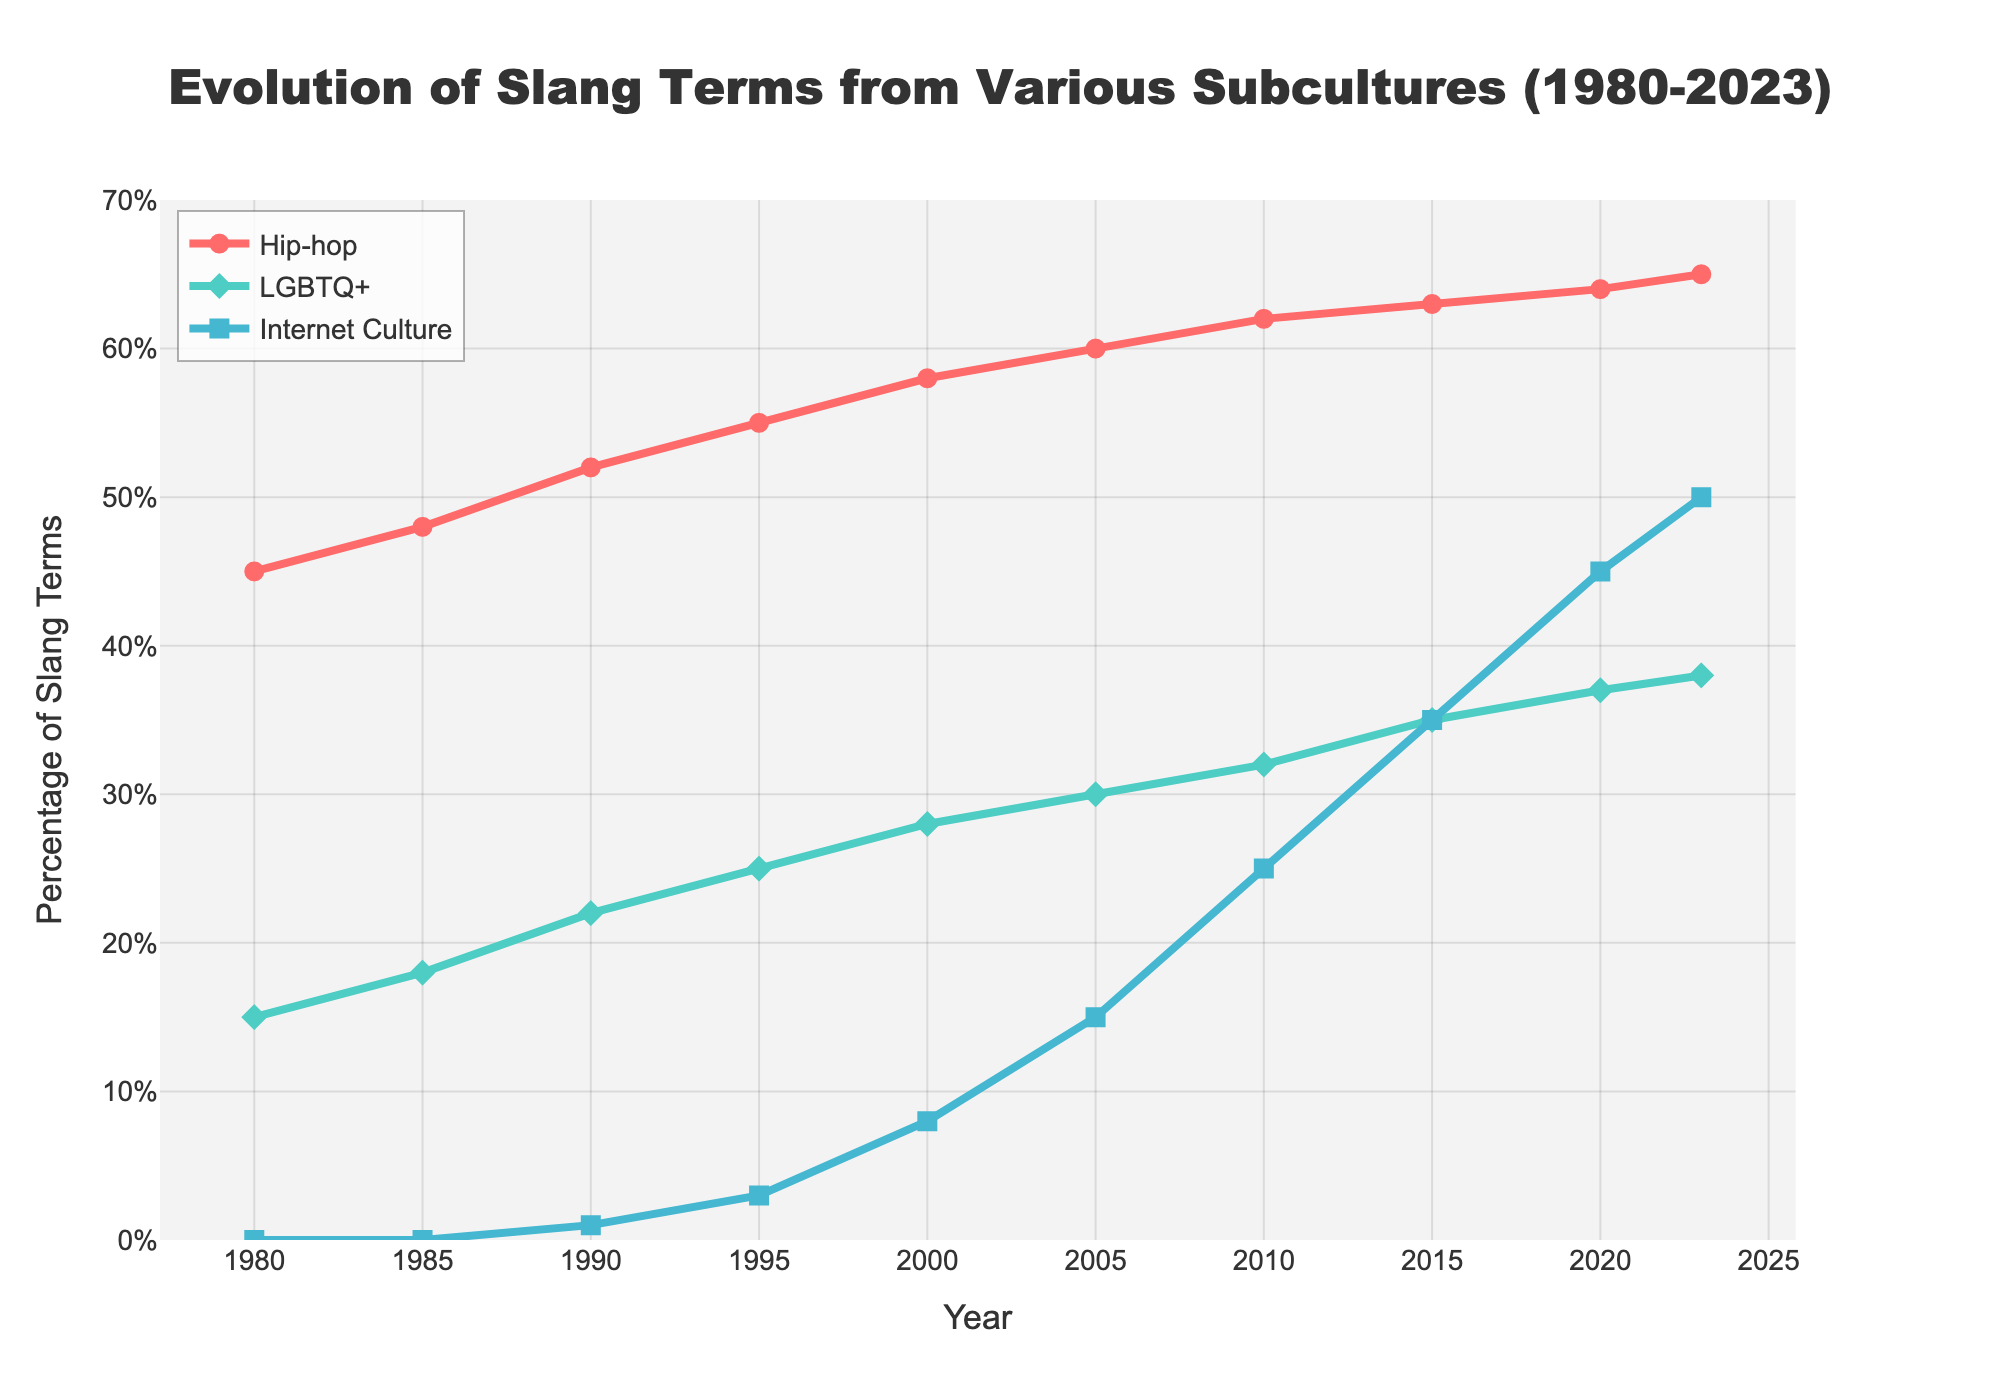What subculture was the origin of 15% of slang terms in 1980? Looking at the plot for the year 1980, the line representing Hip-hop starts around 45%, LGBTQ+ around 15%, and Internet Culture at 0%. Thus, LGBTQ+ is the origin of 15% of slang terms.
Answer: LGBTQ+ In what year did Internet Culture first contribute to slang terms? By checking the lines on the plot, Internet Culture starts showing a contribution starting around 1990 with 1%.
Answer: 1990 Which subculture saw the highest increase in the percentage of slang terms from 2010 to 2020? Calculating the increase for each subculture from 2010 to 2020:
Hip-hop: 64% - 62% = 2%
LGBTQ+: 37% - 32% = 5%
Internet Culture: 45% - 25% = 20% 
Therefore, Internet Culture saw the highest increase.
Answer: Internet Culture Compare the percentage of slang terms from Hip-hop and LGBTQ+ in 1995. Which had a higher percentage and by how much? In 1995, Hip-hop is at 55% and LGBTQ+ at 25%. Therefore, Hip-hop has a higher percentage by 55% - 25% = 30%.
Answer: Hip-hop by 30% What is the trend of slang terms originating from LGBTQ+ from 1980 to 2023? Observing the green line in the graph for LGBTQ+, it consistently increases from 15% in 1980 to 38% in 2023.
Answer: Increasing How much did the percentage of slang terms from Hip-hop increase from 1980 to 2023? From 1980 (45%) to 2023 (65%), the percentage increased by 65% - 45% = 20%.
Answer: 20% At what year did Internet Culture surpass 30% in slang terms and by how much did it increase by 2023? Internet Culture surpassed 30% in 2015 and by 2023, it reached 50%. The increase is 50% - 30% = 20%.
Answer: 2015, 20% What is the combined total percentage of slang terms originating from Hip-hop and LGBTQ+ in 2000? Adding the percentages for Hip-hop (58%) and LGBTQ+ (28%) in 2000 gives a total of 58% + 28% = 86%.
Answer: 86% Which subculture had the smallest percentage growth from 2005 to 2023, and what was the percentage change? Calculating the growth for each subculture:
Hip-hop: 65% - 60% = 5%
LGBTQ+: 38% - 30% = 8%
Internet Culture: 50% - 15% = 35%
Hip-hop had the smallest growth of 5%.
Answer: Hip-hop, 5% 